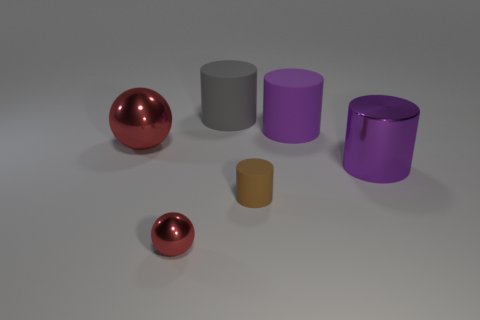What number of gray things are the same size as the brown cylinder?
Your answer should be very brief. 0. Is the number of small things left of the large ball less than the number of tiny yellow blocks?
Provide a succinct answer. No. What number of big matte things are on the left side of the tiny cylinder?
Your response must be concise. 1. There is a metallic thing that is right of the large matte cylinder behind the large matte object that is right of the small brown rubber object; what size is it?
Provide a succinct answer. Large. Do the large gray rubber thing and the big object that is in front of the big red sphere have the same shape?
Provide a succinct answer. Yes. What size is the purple thing that is the same material as the small cylinder?
Your answer should be very brief. Large. Is there any other thing that is the same color as the small cylinder?
Ensure brevity in your answer.  No. What is the material of the purple cylinder that is in front of the ball behind the red ball in front of the big red thing?
Make the answer very short. Metal. How many rubber objects are big purple cylinders or small purple objects?
Ensure brevity in your answer.  1. Is the color of the big ball the same as the small sphere?
Provide a succinct answer. Yes. 